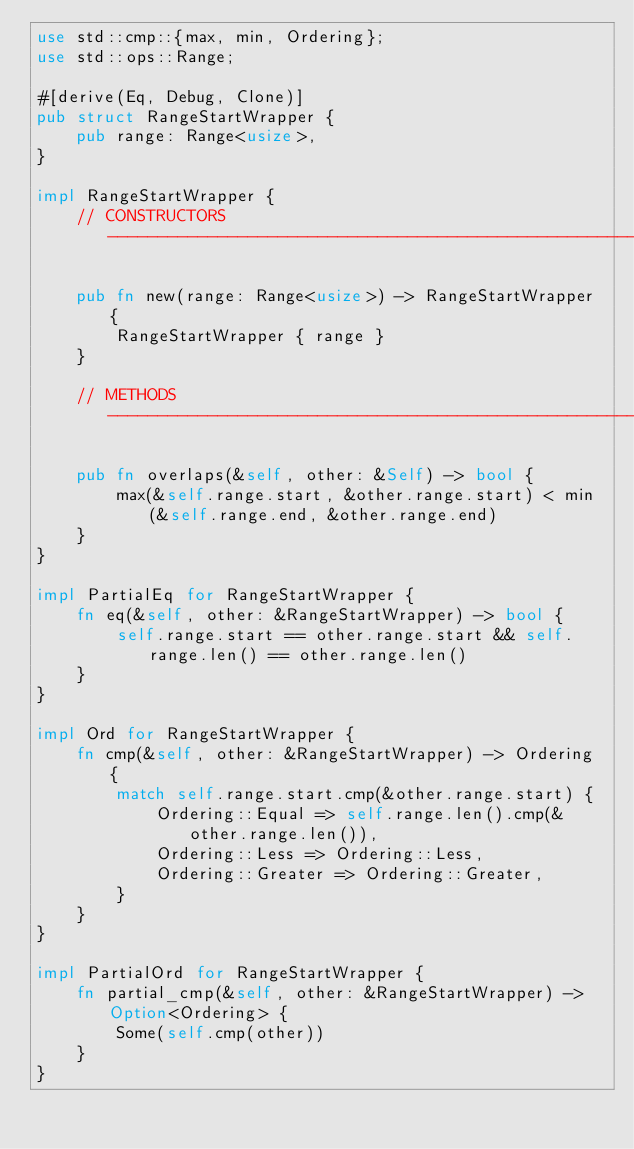Convert code to text. <code><loc_0><loc_0><loc_500><loc_500><_Rust_>use std::cmp::{max, min, Ordering};
use std::ops::Range;

#[derive(Eq, Debug, Clone)]
pub struct RangeStartWrapper {
    pub range: Range<usize>,
}

impl RangeStartWrapper {
    // CONSTRUCTORS -----------------------------------------------------------

    pub fn new(range: Range<usize>) -> RangeStartWrapper {
        RangeStartWrapper { range }
    }

    // METHODS ----------------------------------------------------------------

    pub fn overlaps(&self, other: &Self) -> bool {
        max(&self.range.start, &other.range.start) < min(&self.range.end, &other.range.end)
    }
}

impl PartialEq for RangeStartWrapper {
    fn eq(&self, other: &RangeStartWrapper) -> bool {
        self.range.start == other.range.start && self.range.len() == other.range.len()
    }
}

impl Ord for RangeStartWrapper {
    fn cmp(&self, other: &RangeStartWrapper) -> Ordering {
        match self.range.start.cmp(&other.range.start) {
            Ordering::Equal => self.range.len().cmp(&other.range.len()),
            Ordering::Less => Ordering::Less,
            Ordering::Greater => Ordering::Greater,
        }
    }
}

impl PartialOrd for RangeStartWrapper {
    fn partial_cmp(&self, other: &RangeStartWrapper) -> Option<Ordering> {
        Some(self.cmp(other))
    }
}
</code> 